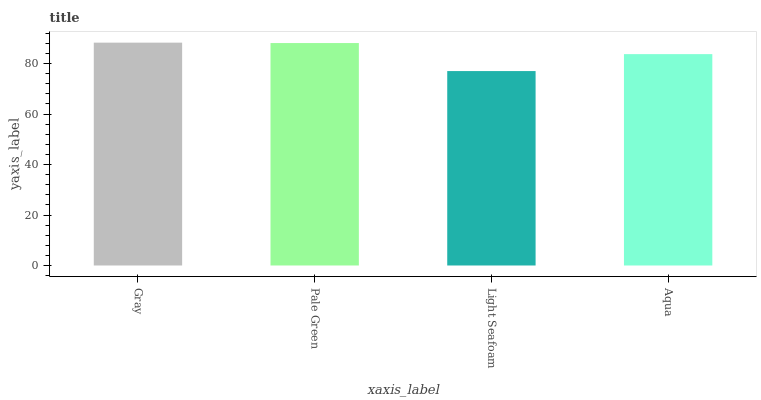Is Pale Green the minimum?
Answer yes or no. No. Is Pale Green the maximum?
Answer yes or no. No. Is Gray greater than Pale Green?
Answer yes or no. Yes. Is Pale Green less than Gray?
Answer yes or no. Yes. Is Pale Green greater than Gray?
Answer yes or no. No. Is Gray less than Pale Green?
Answer yes or no. No. Is Pale Green the high median?
Answer yes or no. Yes. Is Aqua the low median?
Answer yes or no. Yes. Is Light Seafoam the high median?
Answer yes or no. No. Is Gray the low median?
Answer yes or no. No. 